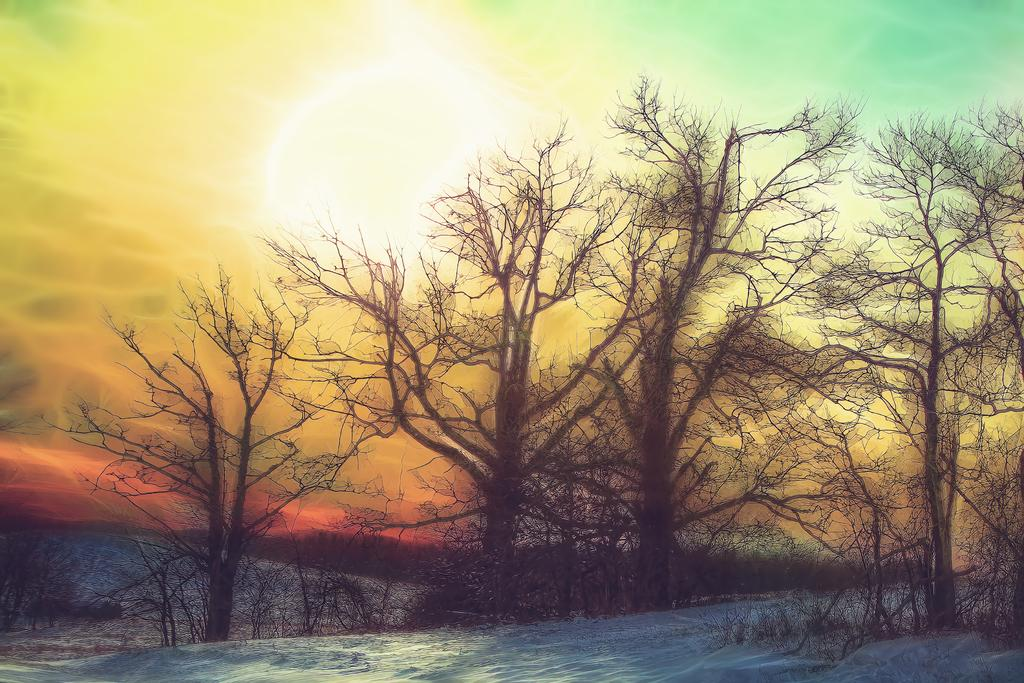What type of vegetation can be seen in the image? There are trees and plants in the image. What is the weather like in the image? There is snow in the image, indicating a cold or wintery environment. What can be seen in the background of the image? The sky is visible in the background of the image. What type of vein is visible in the image? There are no veins present in the image; it features trees, plants, snow, and a visible sky. What type of beef can be seen in the image? There is no beef present in the image. 